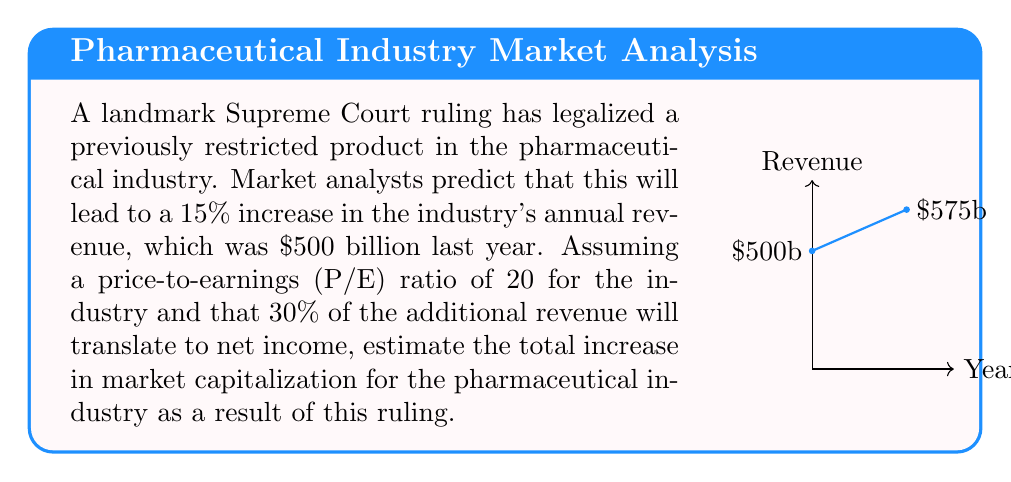What is the answer to this math problem? Let's approach this step-by-step:

1) First, calculate the increase in annual revenue:
   $\text{Revenue increase} = 15\% \times \$500\text{ billion} = \$75\text{ billion}$

2) Now, determine how much of this increase will translate to net income:
   $\text{Net income increase} = 30\% \times \$75\text{ billion} = \$22.5\text{ billion}$

3) The P/E ratio is defined as:
   $$\text{P/E ratio} = \frac{\text{Market Capitalization}}{\text{Net Income}}$$

4) We can rearrange this to find the change in market capitalization:
   $$\Delta\text{Market Capitalization} = \text{P/E ratio} \times \Delta\text{Net Income}$$

5) Plugging in our values:
   $$\Delta\text{Market Capitalization} = 20 \times \$22.5\text{ billion} = \$450\text{ billion}$$

Therefore, the estimated increase in market capitalization for the pharmaceutical industry is $450 billion.
Answer: $450 billion 